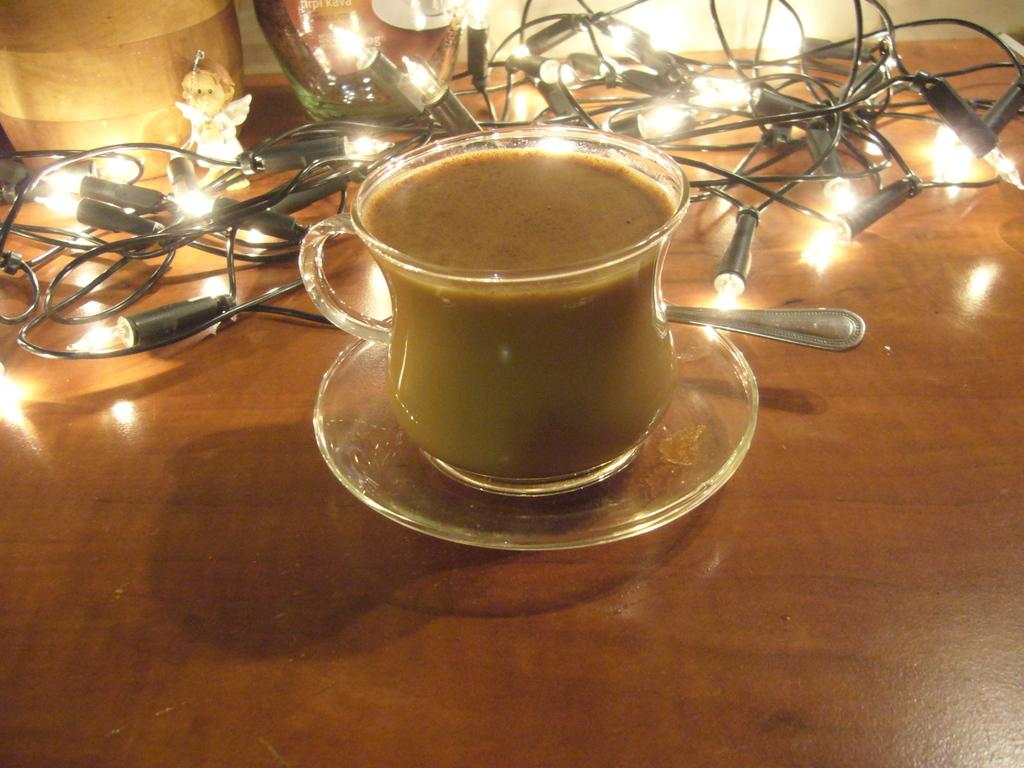What is in the cup that is visible in the image? There is a cup of tea in the image. What is the cup of tea resting on? The cup of tea is on a saucer. What type of lighting is present in the image? There are serial bulbs in the image. What other object can be seen on the table in the image? There is a toy on the table in the image. What utensil is visible in the image? A spoon is visible in the image. How many tomatoes are on the table in the image? There are no tomatoes present in the image. What type of engine can be seen powering the toy in the image? There is no engine present in the image, and the toy does not appear to be powered by any visible mechanism. 